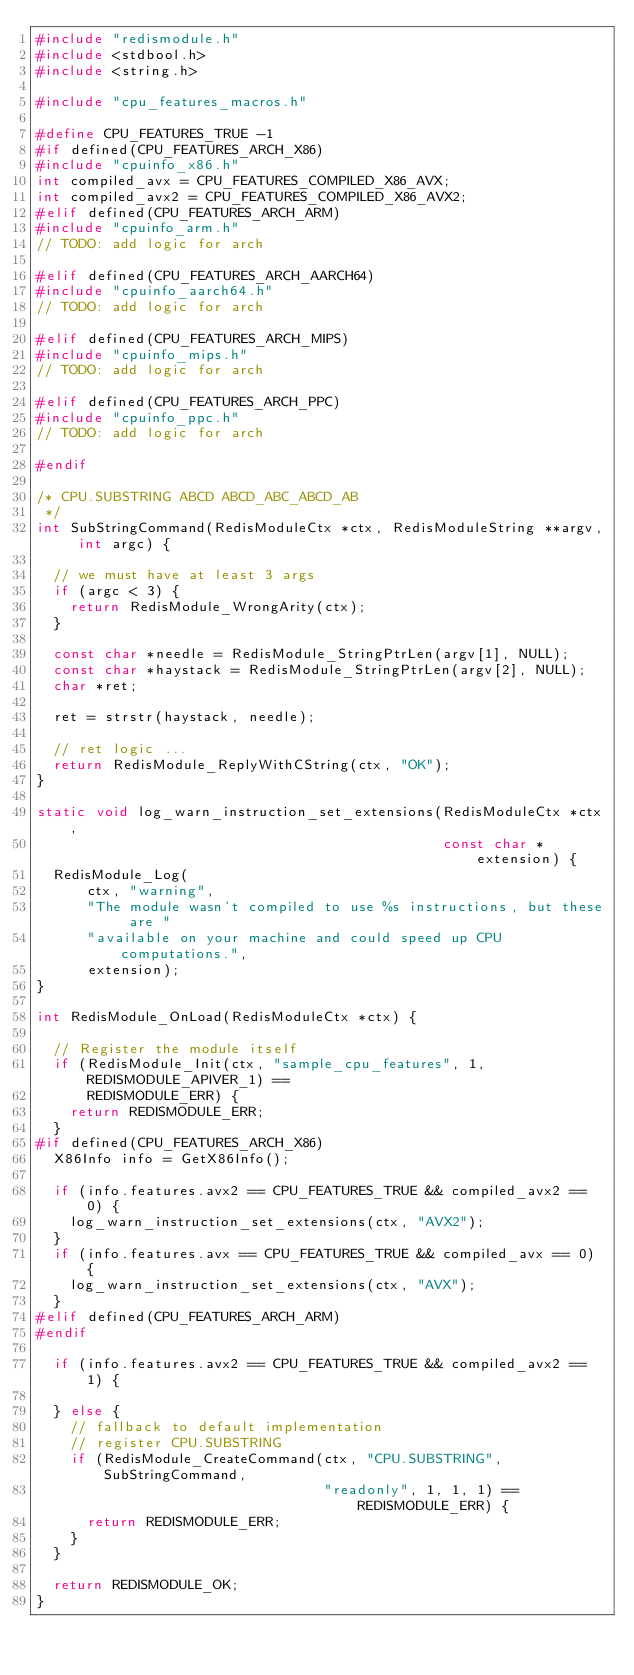<code> <loc_0><loc_0><loc_500><loc_500><_C_>#include "redismodule.h"
#include <stdbool.h>
#include <string.h>

#include "cpu_features_macros.h"

#define CPU_FEATURES_TRUE -1
#if defined(CPU_FEATURES_ARCH_X86)
#include "cpuinfo_x86.h"
int compiled_avx = CPU_FEATURES_COMPILED_X86_AVX;
int compiled_avx2 = CPU_FEATURES_COMPILED_X86_AVX2;
#elif defined(CPU_FEATURES_ARCH_ARM)
#include "cpuinfo_arm.h"
// TODO: add logic for arch

#elif defined(CPU_FEATURES_ARCH_AARCH64)
#include "cpuinfo_aarch64.h"
// TODO: add logic for arch

#elif defined(CPU_FEATURES_ARCH_MIPS)
#include "cpuinfo_mips.h"
// TODO: add logic for arch

#elif defined(CPU_FEATURES_ARCH_PPC)
#include "cpuinfo_ppc.h"
// TODO: add logic for arch

#endif

/* CPU.SUBSTRING ABCD ABCD_ABC_ABCD_AB
 */
int SubStringCommand(RedisModuleCtx *ctx, RedisModuleString **argv, int argc) {

  // we must have at least 3 args
  if (argc < 3) {
    return RedisModule_WrongArity(ctx);
  }

  const char *needle = RedisModule_StringPtrLen(argv[1], NULL);
  const char *haystack = RedisModule_StringPtrLen(argv[2], NULL);
  char *ret;

  ret = strstr(haystack, needle);

  // ret logic ...
  return RedisModule_ReplyWithCString(ctx, "OK");
}

static void log_warn_instruction_set_extensions(RedisModuleCtx *ctx,
                                                const char *extension) {
  RedisModule_Log(
      ctx, "warning",
      "The module wasn't compiled to use %s instructions, but these are "
      "available on your machine and could speed up CPU computations.",
      extension);
}

int RedisModule_OnLoad(RedisModuleCtx *ctx) {

  // Register the module itself
  if (RedisModule_Init(ctx, "sample_cpu_features", 1, REDISMODULE_APIVER_1) ==
      REDISMODULE_ERR) {
    return REDISMODULE_ERR;
  }
#if defined(CPU_FEATURES_ARCH_X86)
  X86Info info = GetX86Info();

  if (info.features.avx2 == CPU_FEATURES_TRUE && compiled_avx2 == 0) {
    log_warn_instruction_set_extensions(ctx, "AVX2");
  }
  if (info.features.avx == CPU_FEATURES_TRUE && compiled_avx == 0) {
    log_warn_instruction_set_extensions(ctx, "AVX");
  }
#elif defined(CPU_FEATURES_ARCH_ARM)
#endif

  if (info.features.avx2 == CPU_FEATURES_TRUE && compiled_avx2 == 1) {

  } else {
    // fallback to default implementation
    // register CPU.SUBSTRING
    if (RedisModule_CreateCommand(ctx, "CPU.SUBSTRING", SubStringCommand,
                                  "readonly", 1, 1, 1) == REDISMODULE_ERR) {
      return REDISMODULE_ERR;
    }
  }

  return REDISMODULE_OK;
}</code> 